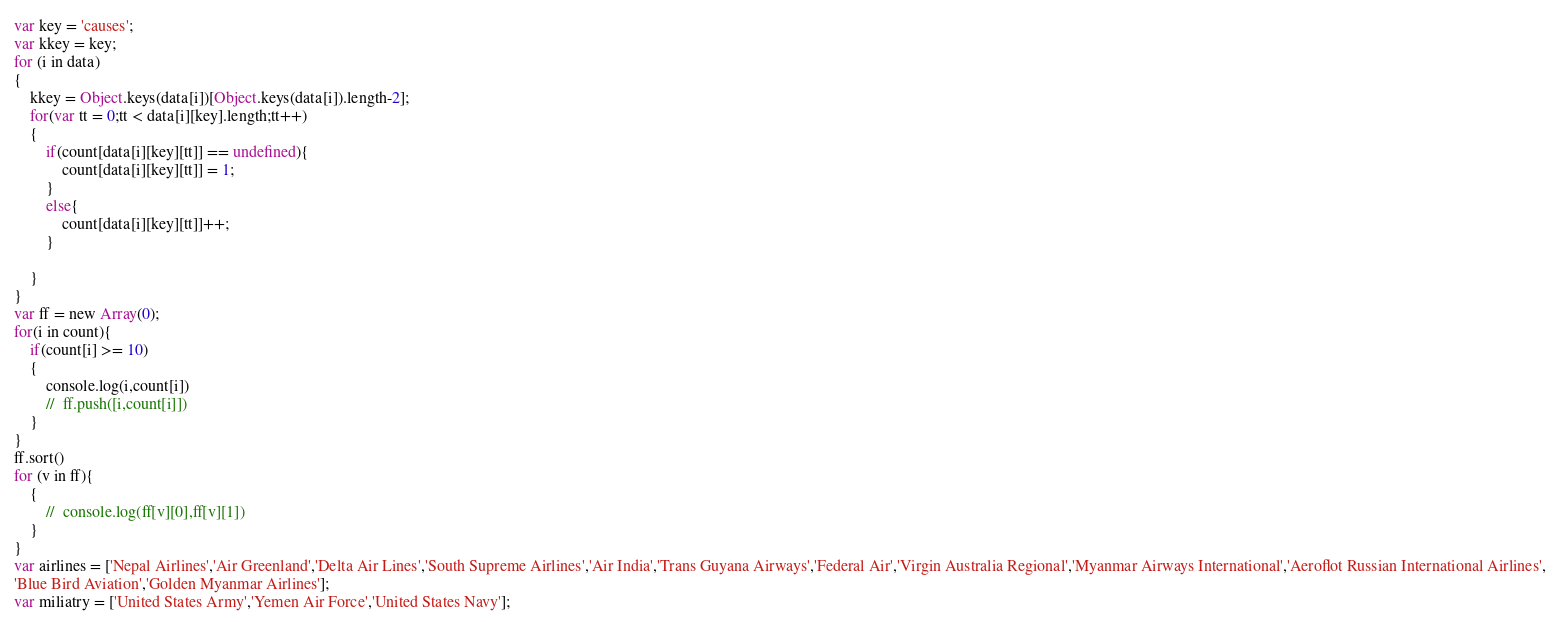Convert code to text. <code><loc_0><loc_0><loc_500><loc_500><_JavaScript_>var key = 'causes';
var kkey = key;
for (i in data)
{
	kkey = Object.keys(data[i])[Object.keys(data[i]).length-2];
	for(var tt = 0;tt < data[i][key].length;tt++)
	{
		if(count[data[i][key][tt]] == undefined){
			count[data[i][key][tt]] = 1;
		}
		else{
			count[data[i][key][tt]]++;
		}

	}
}
var ff = new Array(0);
for(i in count){
	if(count[i] >= 10)
	{
		console.log(i,count[i])
		//	ff.push([i,count[i]])
	}
}
ff.sort()
for (v in ff){
	{
		//	console.log(ff[v][0],ff[v][1])
	}
}
var airlines = ['Nepal Airlines','Air Greenland','Delta Air Lines','South Supreme Airlines','Air India','Trans Guyana Airways','Federal Air','Virgin Australia Regional','Myanmar Airways International','Aeroflot Russian International Airlines',
'Blue Bird Aviation','Golden Myanmar Airlines'];
var miliatry = ['United States Army','Yemen Air Force','United States Navy'];
</code> 